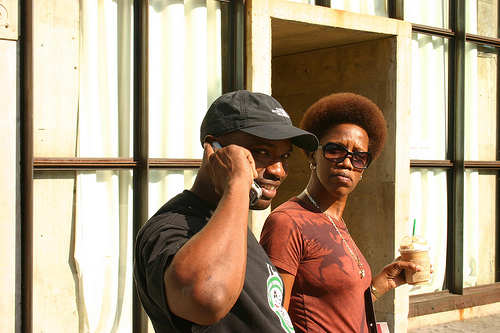What time of day does it seem to be based on the lighting in the image? Judging by the shadows and the quality of the light, it appears to be daytime with bright sunlight, likely midday or early afternoon when the sun is high, as there are strong shadows visible on the ground and along the building. 